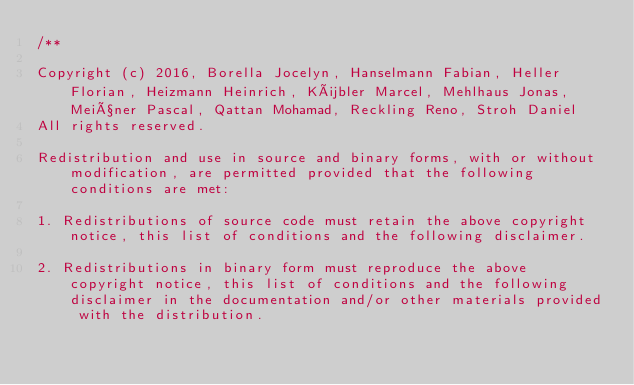Convert code to text. <code><loc_0><loc_0><loc_500><loc_500><_C++_>/**

Copyright (c) 2016, Borella Jocelyn, Hanselmann Fabian, Heller Florian, Heizmann Heinrich, Kübler Marcel, Mehlhaus Jonas, Meißner Pascal, Qattan Mohamad, Reckling Reno, Stroh Daniel
All rights reserved.

Redistribution and use in source and binary forms, with or without modification, are permitted provided that the following conditions are met:

1. Redistributions of source code must retain the above copyright notice, this list of conditions and the following disclaimer.

2. Redistributions in binary form must reproduce the above copyright notice, this list of conditions and the following disclaimer in the documentation and/or other materials provided with the distribution.
</code> 